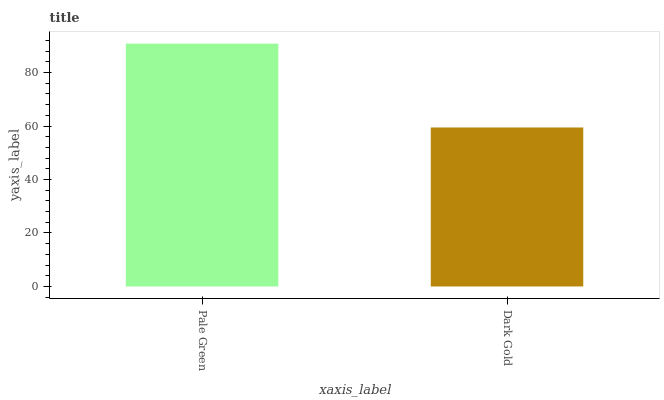Is Dark Gold the minimum?
Answer yes or no. Yes. Is Pale Green the maximum?
Answer yes or no. Yes. Is Dark Gold the maximum?
Answer yes or no. No. Is Pale Green greater than Dark Gold?
Answer yes or no. Yes. Is Dark Gold less than Pale Green?
Answer yes or no. Yes. Is Dark Gold greater than Pale Green?
Answer yes or no. No. Is Pale Green less than Dark Gold?
Answer yes or no. No. Is Pale Green the high median?
Answer yes or no. Yes. Is Dark Gold the low median?
Answer yes or no. Yes. Is Dark Gold the high median?
Answer yes or no. No. Is Pale Green the low median?
Answer yes or no. No. 